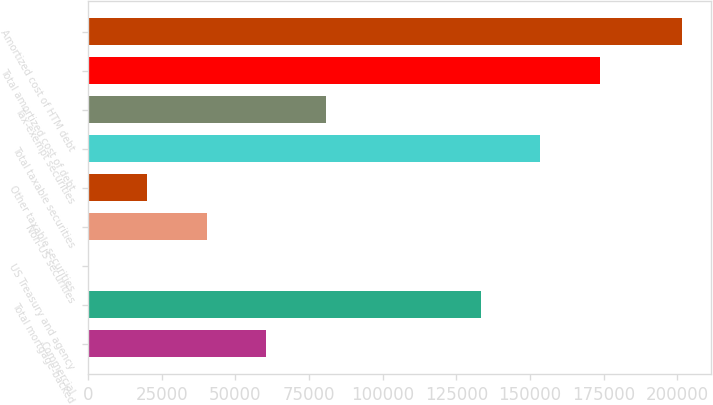Convert chart to OTSL. <chart><loc_0><loc_0><loc_500><loc_500><bar_chart><fcel>Commercial<fcel>Total mortgage-backed<fcel>US Treasury and agency<fcel>Non-US securities<fcel>Other taxable securities<fcel>Total taxable securities<fcel>Tax-exempt securities<fcel>Total amortized cost of debt<fcel>Amortized cost of HTM debt<nl><fcel>60465.3<fcel>133444<fcel>21<fcel>40317.2<fcel>20169.1<fcel>153592<fcel>80613.4<fcel>173740<fcel>201502<nl></chart> 